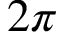<formula> <loc_0><loc_0><loc_500><loc_500>2 \pi</formula> 